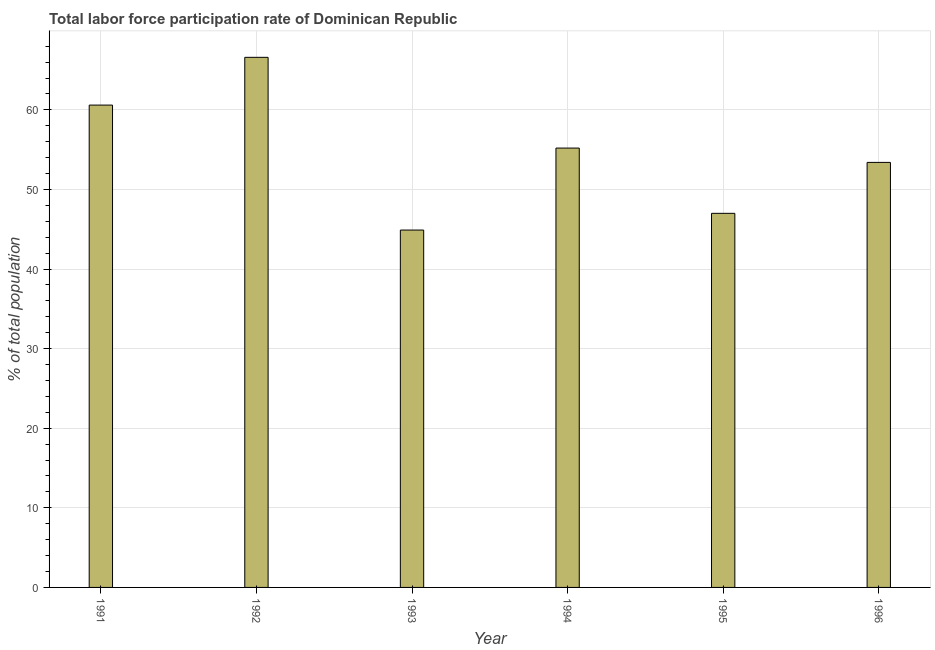Does the graph contain grids?
Provide a succinct answer. Yes. What is the title of the graph?
Your response must be concise. Total labor force participation rate of Dominican Republic. What is the label or title of the X-axis?
Provide a succinct answer. Year. What is the label or title of the Y-axis?
Offer a very short reply. % of total population. What is the total labor force participation rate in 1991?
Provide a short and direct response. 60.6. Across all years, what is the maximum total labor force participation rate?
Keep it short and to the point. 66.6. Across all years, what is the minimum total labor force participation rate?
Provide a short and direct response. 44.9. In which year was the total labor force participation rate minimum?
Offer a very short reply. 1993. What is the sum of the total labor force participation rate?
Keep it short and to the point. 327.7. What is the average total labor force participation rate per year?
Keep it short and to the point. 54.62. What is the median total labor force participation rate?
Provide a succinct answer. 54.3. What is the ratio of the total labor force participation rate in 1991 to that in 1993?
Make the answer very short. 1.35. Is the sum of the total labor force participation rate in 1994 and 1996 greater than the maximum total labor force participation rate across all years?
Provide a succinct answer. Yes. What is the difference between the highest and the lowest total labor force participation rate?
Ensure brevity in your answer.  21.7. How many bars are there?
Keep it short and to the point. 6. How many years are there in the graph?
Keep it short and to the point. 6. Are the values on the major ticks of Y-axis written in scientific E-notation?
Offer a terse response. No. What is the % of total population in 1991?
Your answer should be compact. 60.6. What is the % of total population in 1992?
Your answer should be compact. 66.6. What is the % of total population of 1993?
Offer a terse response. 44.9. What is the % of total population of 1994?
Provide a succinct answer. 55.2. What is the % of total population in 1996?
Your answer should be compact. 53.4. What is the difference between the % of total population in 1991 and 1992?
Keep it short and to the point. -6. What is the difference between the % of total population in 1991 and 1995?
Your response must be concise. 13.6. What is the difference between the % of total population in 1992 and 1993?
Offer a terse response. 21.7. What is the difference between the % of total population in 1992 and 1995?
Make the answer very short. 19.6. What is the difference between the % of total population in 1992 and 1996?
Offer a terse response. 13.2. What is the difference between the % of total population in 1993 and 1994?
Your answer should be compact. -10.3. What is the difference between the % of total population in 1993 and 1995?
Provide a succinct answer. -2.1. What is the difference between the % of total population in 1993 and 1996?
Give a very brief answer. -8.5. What is the difference between the % of total population in 1994 and 1995?
Give a very brief answer. 8.2. What is the difference between the % of total population in 1994 and 1996?
Offer a very short reply. 1.8. What is the ratio of the % of total population in 1991 to that in 1992?
Your response must be concise. 0.91. What is the ratio of the % of total population in 1991 to that in 1993?
Offer a very short reply. 1.35. What is the ratio of the % of total population in 1991 to that in 1994?
Offer a very short reply. 1.1. What is the ratio of the % of total population in 1991 to that in 1995?
Provide a succinct answer. 1.29. What is the ratio of the % of total population in 1991 to that in 1996?
Your answer should be compact. 1.14. What is the ratio of the % of total population in 1992 to that in 1993?
Your answer should be very brief. 1.48. What is the ratio of the % of total population in 1992 to that in 1994?
Provide a succinct answer. 1.21. What is the ratio of the % of total population in 1992 to that in 1995?
Ensure brevity in your answer.  1.42. What is the ratio of the % of total population in 1992 to that in 1996?
Make the answer very short. 1.25. What is the ratio of the % of total population in 1993 to that in 1994?
Your answer should be compact. 0.81. What is the ratio of the % of total population in 1993 to that in 1995?
Your answer should be very brief. 0.95. What is the ratio of the % of total population in 1993 to that in 1996?
Make the answer very short. 0.84. What is the ratio of the % of total population in 1994 to that in 1995?
Offer a very short reply. 1.17. What is the ratio of the % of total population in 1994 to that in 1996?
Make the answer very short. 1.03. What is the ratio of the % of total population in 1995 to that in 1996?
Make the answer very short. 0.88. 